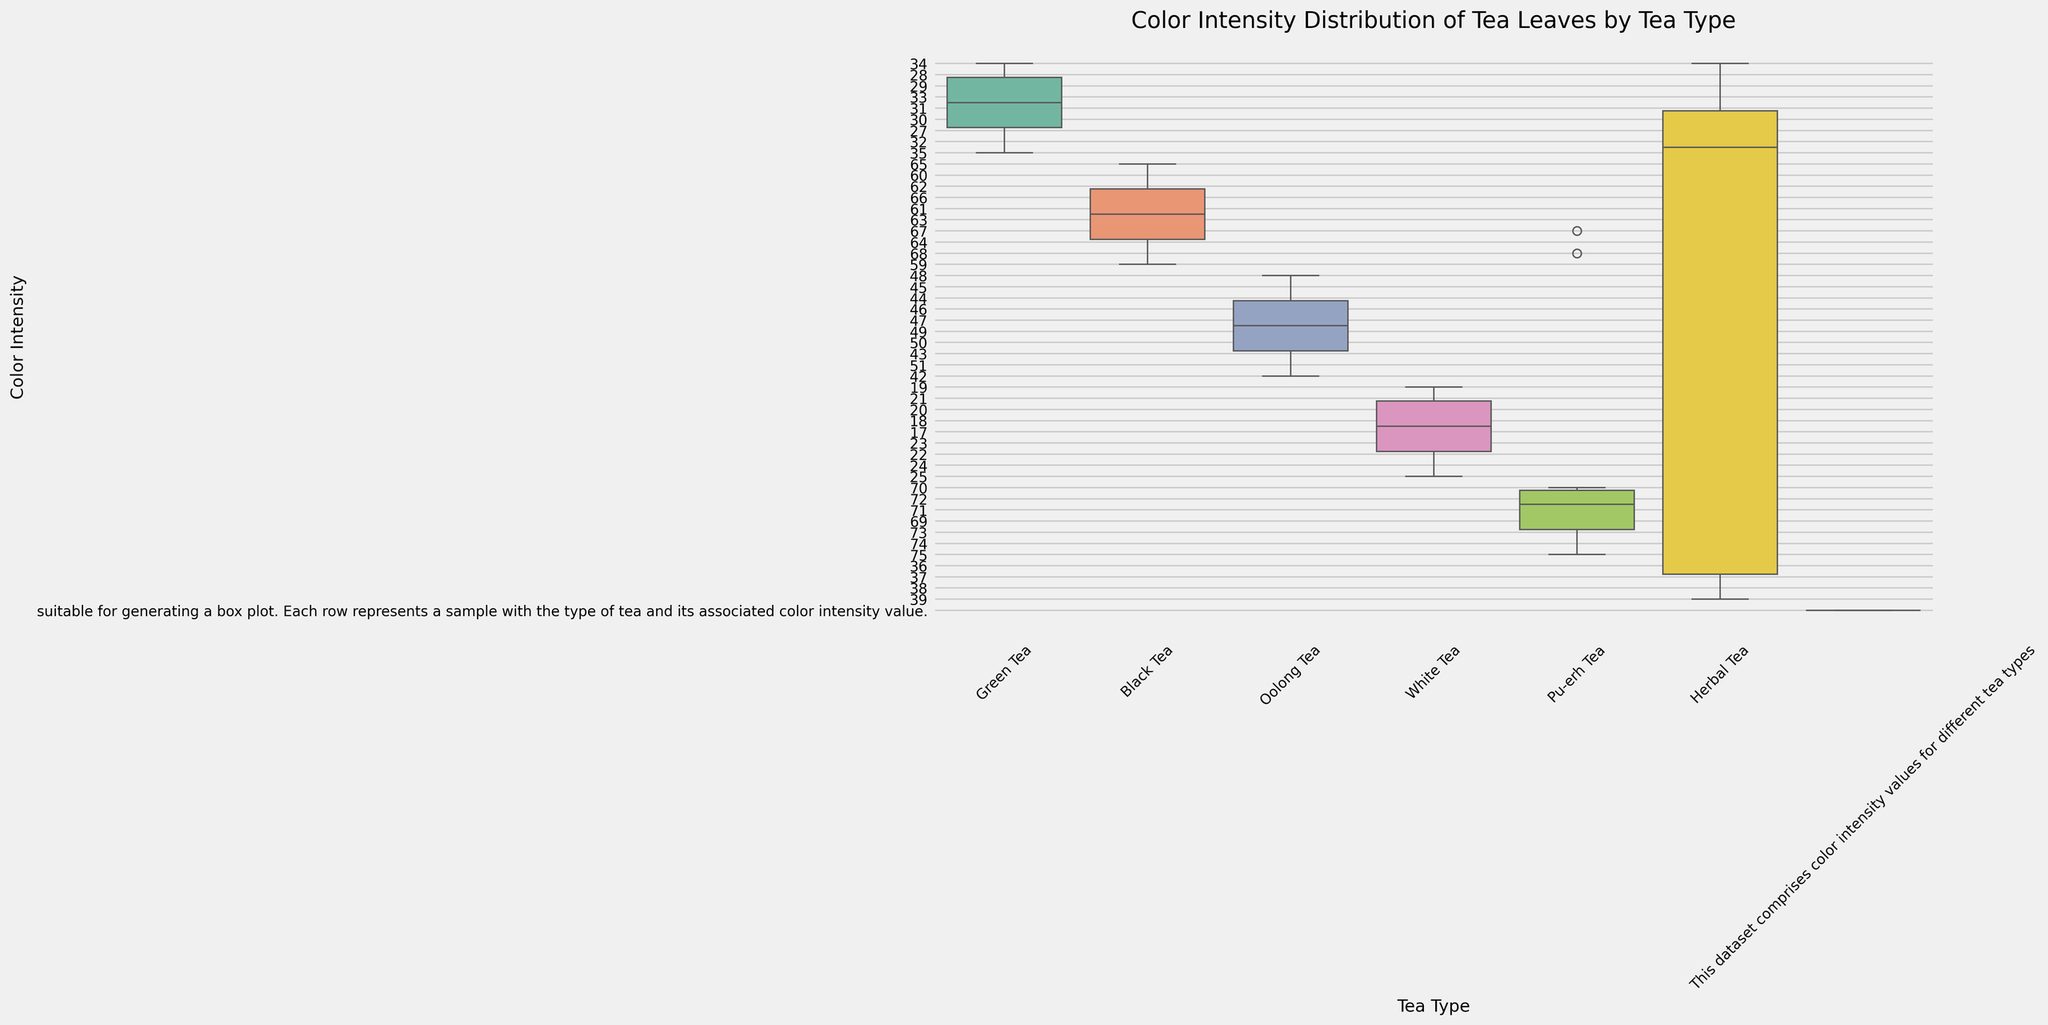What is the median color intensity for Black Tea? The median is the middle value in a sorted list. When we sort the Color Intensity values for Black Tea (59, 60, 61, 62, 63, 64, 65, 66, 67, 68), the middle values are 63 and 64. The median is the average of these two values, which is (63 + 64) / 2 = 63.5
Answer: 63.5 Which tea type has the highest median color intensity? To find this, compare the median values of each tea type. By examining the visual representation of each box plot's center, Pu-erh Tea has the highest median as its middle line is higher than that of the other tea types.
Answer: Pu-erh Tea Which tea type shows the lowest minimum color intensity? The minimum color intensity is indicated by the lowest point at the bottom of the whiskers in each box plot. White Tea has the lowest minimum color intensity, situated at around 17.
Answer: White Tea What is the interquartile range (IQR) for Oolong Tea? The IQR is the range between the first quartile (Q1) and the third quartile (Q3). For Oolong Tea, find the values at the bottom and top of the box. Suppose Q1 is around 44 and Q3 around 49, the IQR is 49 - 44 = 5.
Answer: 5 How do the color intensity distributions of Green Tea and Herbal Tea compare in terms of median values? Compare the medians (middle line) of the boxes for Green Tea and Herbal Tea. Green Tea's median is around 30, while Herbal Tea's is around 35, indicating Herbal Tea has a higher median.
Answer: Herbal Tea has a higher median Which tea type has the greatest spread of color intensity values? The spread can be assessed by the length of the whiskers and the range of the box. Pu-erh Tea has the greatest spread, indicating the widest range of values.
Answer: Pu-erh Tea Of the teas listed, which one has the least variation in color intensity? Variation can be observed by examining the compactness of the box and whiskers. White Tea has the shortest whiskers, suggesting the least variation in its color intensity values.
Answer: White Tea Between Black Tea and Oolong Tea, which tea type has a higher third quartile (Q3)? The third quartile is the top of the box. Black Tea's Q3 is around 66, while Oolong Tea's Q3 is around 49. Therefore, Black Tea has a higher Q3.
Answer: Black Tea Identify the tea type with the highest outlier value and specify what it is if any. Outliers are indicated by points outside the whiskers. From the visual inspection, there doesn't seem to be any outliers in the provided data range for all tea types, so none explicitly identified.
Answer: None 